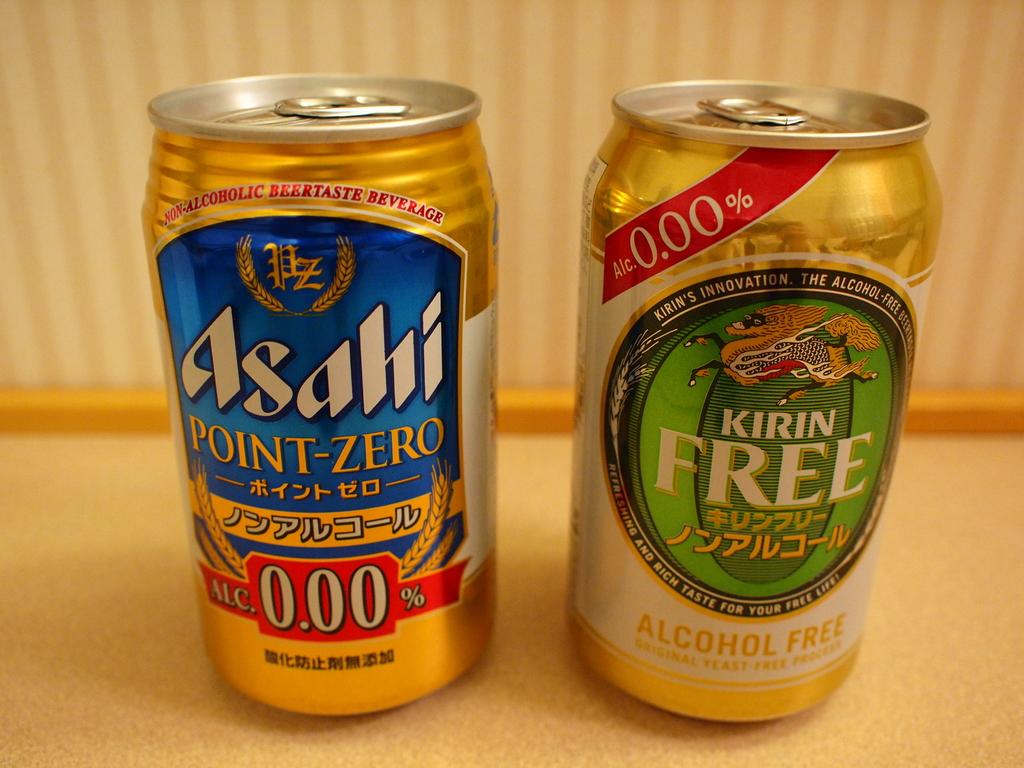What is the name of the one with a blue background?
Your answer should be compact. Asahi point-zero. 